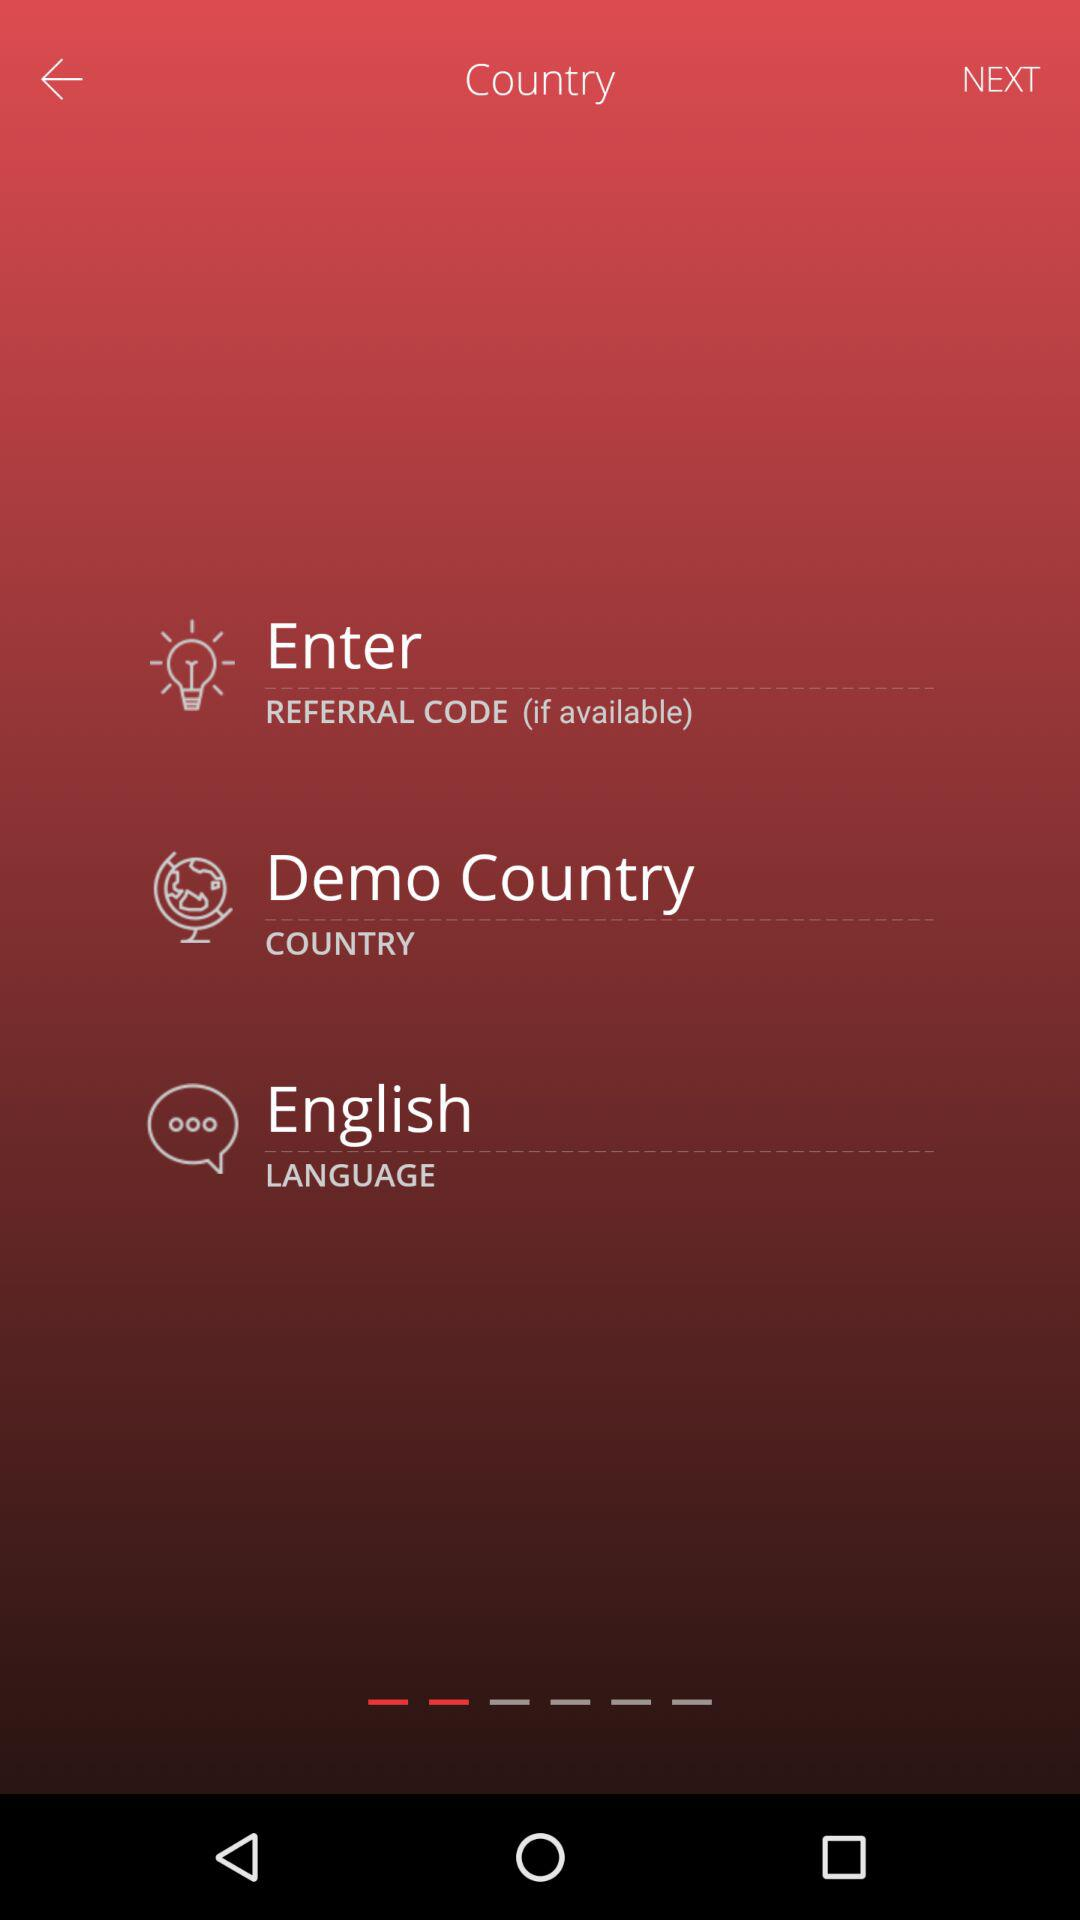Which language is selected? The selected language is English. 